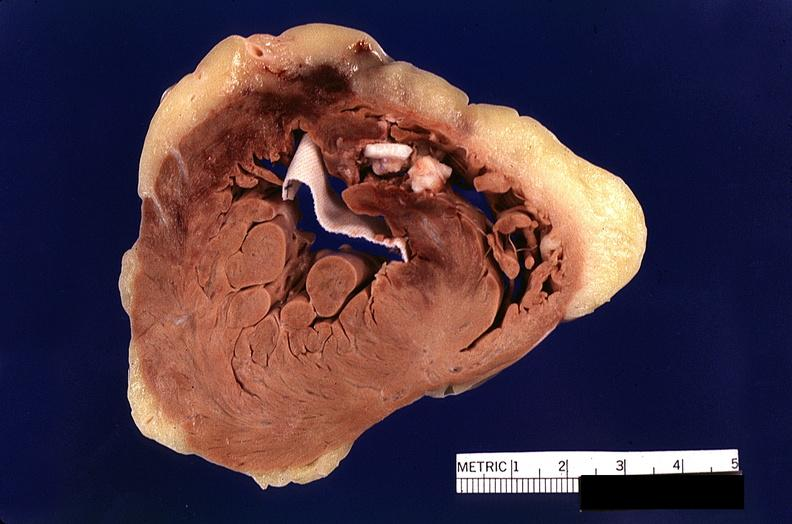what does this image show?
Answer the question using a single word or phrase. Heart 